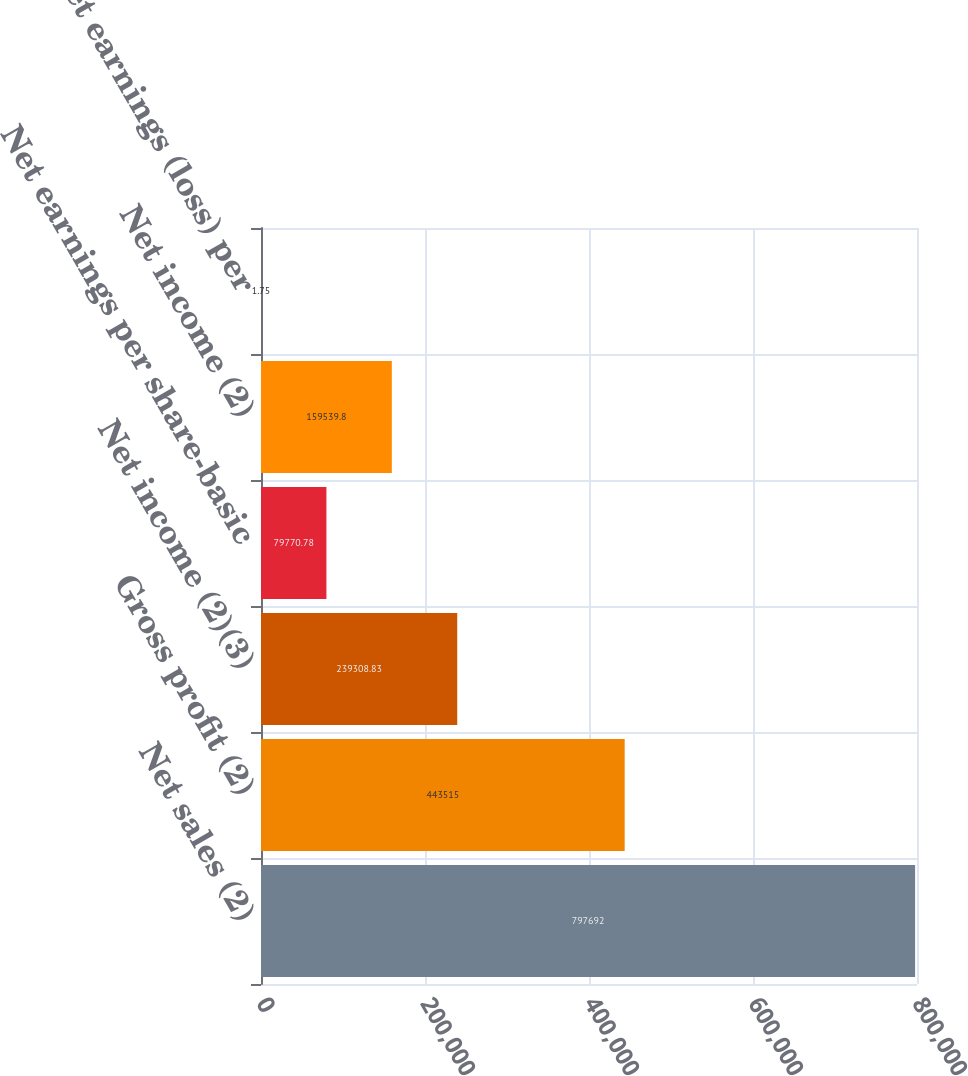<chart> <loc_0><loc_0><loc_500><loc_500><bar_chart><fcel>Net sales (2)<fcel>Gross profit (2)<fcel>Net income (2)(3)<fcel>Net earnings per share-basic<fcel>Net income (2)<fcel>Net earnings (loss) per<nl><fcel>797692<fcel>443515<fcel>239309<fcel>79770.8<fcel>159540<fcel>1.75<nl></chart> 